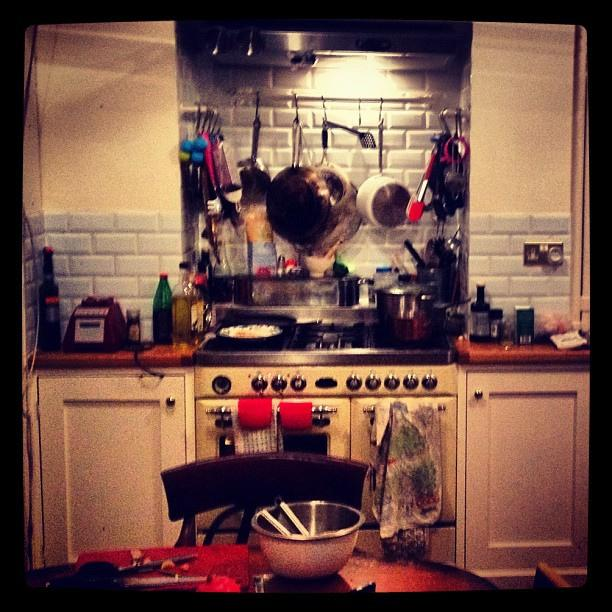What items are found on the wall?

Choices:
A) posters
B) hams
C) pots
D) sausages pots 